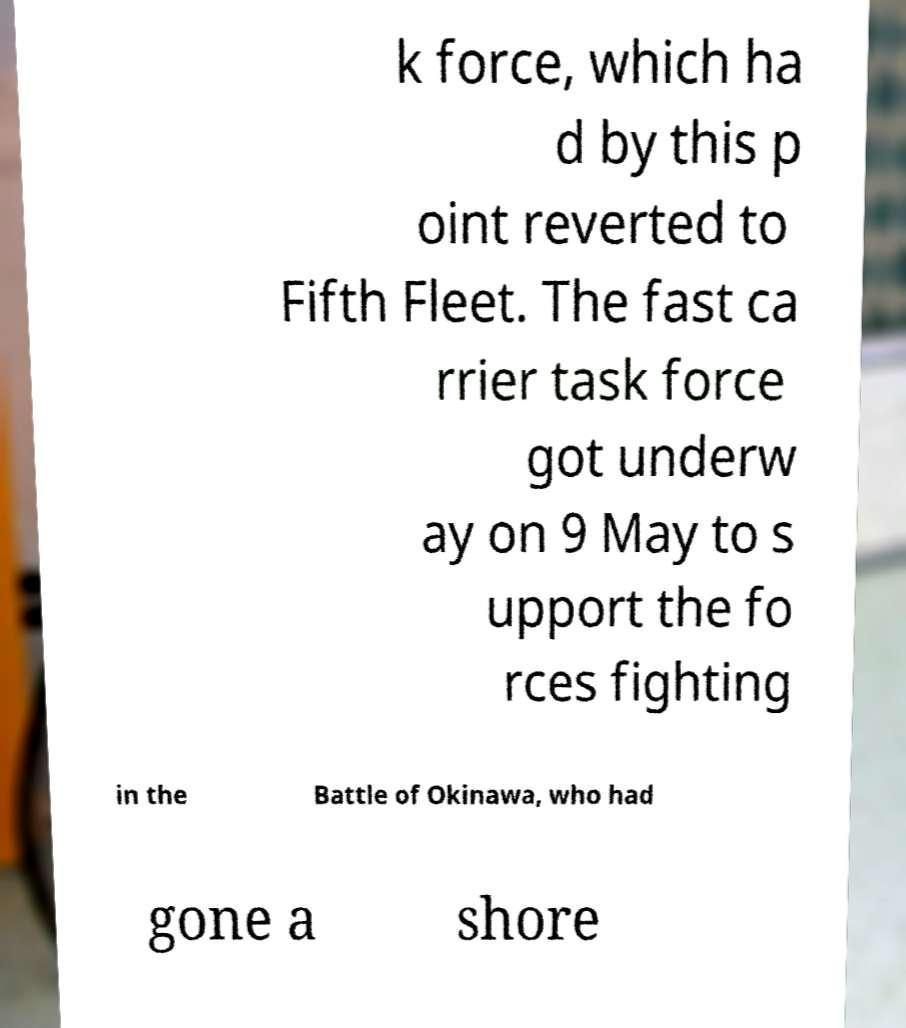Please identify and transcribe the text found in this image. k force, which ha d by this p oint reverted to Fifth Fleet. The fast ca rrier task force got underw ay on 9 May to s upport the fo rces fighting in the Battle of Okinawa, who had gone a shore 